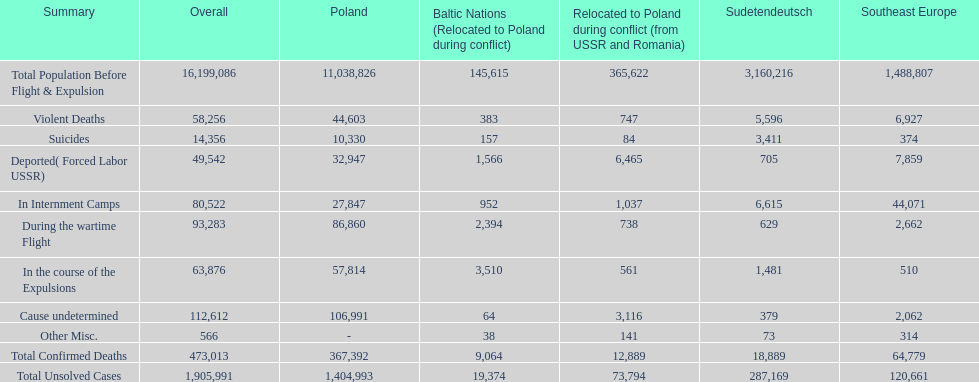What is the total number of violent deaths across all regions? 58,256. 